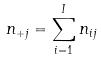Convert formula to latex. <formula><loc_0><loc_0><loc_500><loc_500>n _ { + j } = \sum _ { i = 1 } ^ { I } n _ { i j }</formula> 